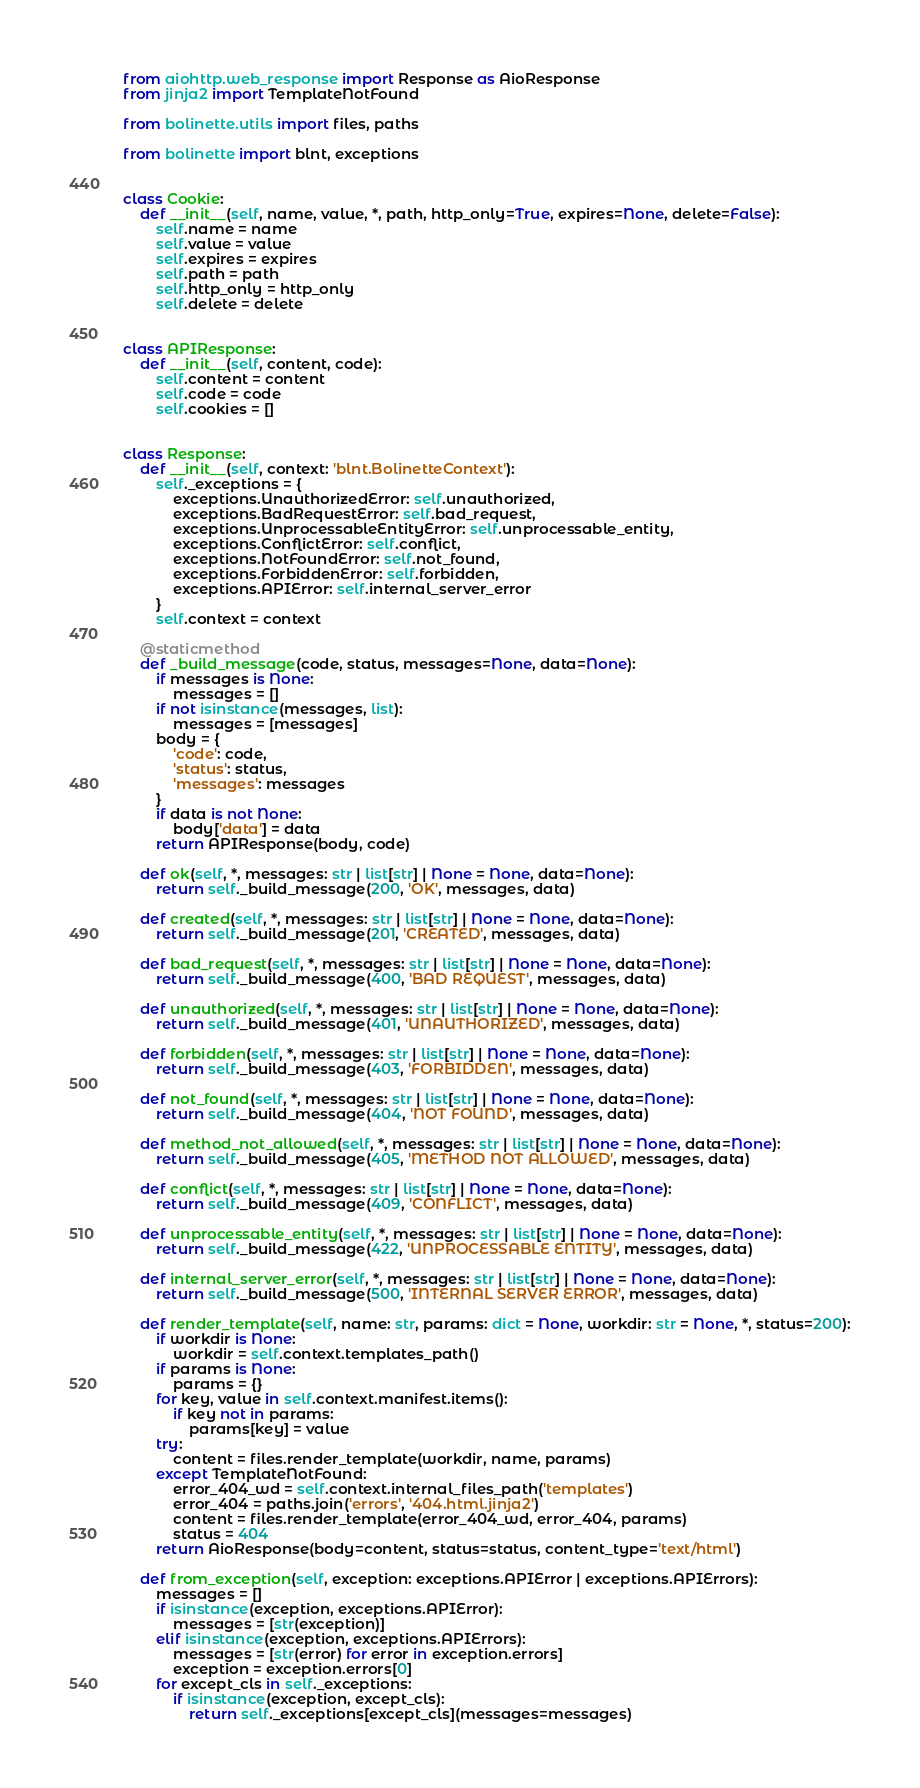Convert code to text. <code><loc_0><loc_0><loc_500><loc_500><_Python_>from aiohttp.web_response import Response as AioResponse
from jinja2 import TemplateNotFound

from bolinette.utils import files, paths

from bolinette import blnt, exceptions


class Cookie:
    def __init__(self, name, value, *, path, http_only=True, expires=None, delete=False):
        self.name = name
        self.value = value
        self.expires = expires
        self.path = path
        self.http_only = http_only
        self.delete = delete


class APIResponse:
    def __init__(self, content, code):
        self.content = content
        self.code = code
        self.cookies = []


class Response:
    def __init__(self, context: 'blnt.BolinetteContext'):
        self._exceptions = {
            exceptions.UnauthorizedError: self.unauthorized,
            exceptions.BadRequestError: self.bad_request,
            exceptions.UnprocessableEntityError: self.unprocessable_entity,
            exceptions.ConflictError: self.conflict,
            exceptions.NotFoundError: self.not_found,
            exceptions.ForbiddenError: self.forbidden,
            exceptions.APIError: self.internal_server_error
        }
        self.context = context

    @staticmethod
    def _build_message(code, status, messages=None, data=None):
        if messages is None:
            messages = []
        if not isinstance(messages, list):
            messages = [messages]
        body = {
            'code': code,
            'status': status,
            'messages': messages
        }
        if data is not None:
            body['data'] = data
        return APIResponse(body, code)

    def ok(self, *, messages: str | list[str] | None = None, data=None):
        return self._build_message(200, 'OK', messages, data)

    def created(self, *, messages: str | list[str] | None = None, data=None):
        return self._build_message(201, 'CREATED', messages, data)

    def bad_request(self, *, messages: str | list[str] | None = None, data=None):
        return self._build_message(400, 'BAD REQUEST', messages, data)

    def unauthorized(self, *, messages: str | list[str] | None = None, data=None):
        return self._build_message(401, 'UNAUTHORIZED', messages, data)

    def forbidden(self, *, messages: str | list[str] | None = None, data=None):
        return self._build_message(403, 'FORBIDDEN', messages, data)

    def not_found(self, *, messages: str | list[str] | None = None, data=None):
        return self._build_message(404, 'NOT FOUND', messages, data)

    def method_not_allowed(self, *, messages: str | list[str] | None = None, data=None):
        return self._build_message(405, 'METHOD NOT ALLOWED', messages, data)

    def conflict(self, *, messages: str | list[str] | None = None, data=None):
        return self._build_message(409, 'CONFLICT', messages, data)

    def unprocessable_entity(self, *, messages: str | list[str] | None = None, data=None):
        return self._build_message(422, 'UNPROCESSABLE ENTITY', messages, data)

    def internal_server_error(self, *, messages: str | list[str] | None = None, data=None):
        return self._build_message(500, 'INTERNAL SERVER ERROR', messages, data)

    def render_template(self, name: str, params: dict = None, workdir: str = None, *, status=200):
        if workdir is None:
            workdir = self.context.templates_path()
        if params is None:
            params = {}
        for key, value in self.context.manifest.items():
            if key not in params:
                params[key] = value
        try:
            content = files.render_template(workdir, name, params)
        except TemplateNotFound:
            error_404_wd = self.context.internal_files_path('templates')
            error_404 = paths.join('errors', '404.html.jinja2')
            content = files.render_template(error_404_wd, error_404, params)
            status = 404
        return AioResponse(body=content, status=status, content_type='text/html')

    def from_exception(self, exception: exceptions.APIError | exceptions.APIErrors):
        messages = []
        if isinstance(exception, exceptions.APIError):
            messages = [str(exception)]
        elif isinstance(exception, exceptions.APIErrors):
            messages = [str(error) for error in exception.errors]
            exception = exception.errors[0]
        for except_cls in self._exceptions:
            if isinstance(exception, except_cls):
                return self._exceptions[except_cls](messages=messages)
</code> 